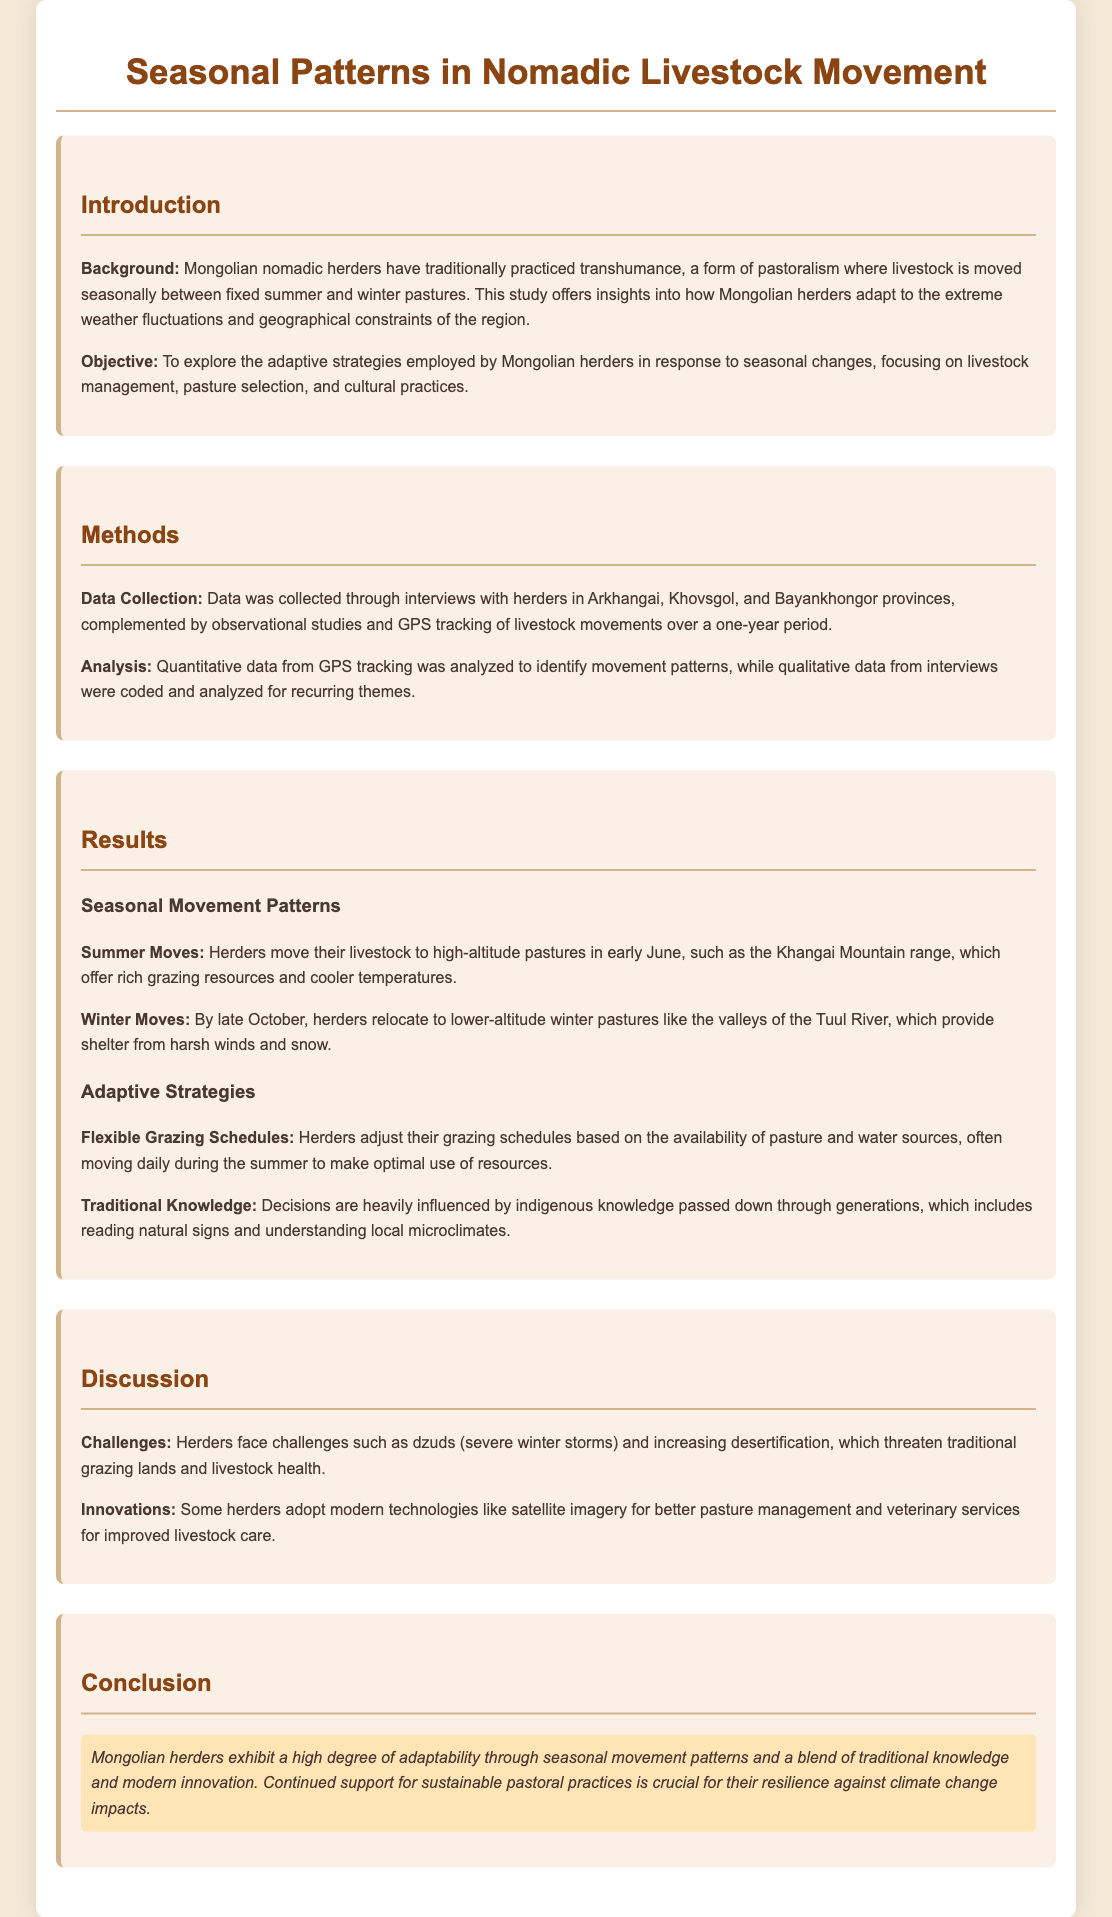What is the study about? The study focuses on the adaptation strategies of Mongolian herders in response to seasonal changes in livestock movement.
Answer: Adaptation strategies of Mongolian herders What provinces were included in the data collection? The data was collected in Arkhangai, Khovsgol, and Bayankhongor provinces.
Answer: Arkhangai, Khovsgol, Bayankhongor When do herders typically move their livestock to summer pastures? Herders move their livestock to high-altitude pastures in early June.
Answer: Early June What is a major challenge faced by herders? Herders face challenges such as dzuds (severe winter storms) and increasing desertification.
Answer: Dzuds What type of traditional knowledge do herders utilize? Herders use indigenous knowledge, including reading natural signs and understanding local microclimates.
Answer: Indigenous knowledge What modern technology is adopted by some herders? Some herders adopt satellite imagery for better pasture management.
Answer: Satellite imagery What is the highlighted conclusion of the study? The conclusion emphasizes the adaptability of Mongolian herders through traditional knowledge and modern innovation.
Answer: High degree of adaptability 